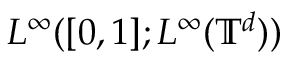Convert formula to latex. <formula><loc_0><loc_0><loc_500><loc_500>L ^ { \infty } ( [ 0 , 1 ] ; L ^ { \infty } ( { \mathbb { T } } ^ { d } ) )</formula> 